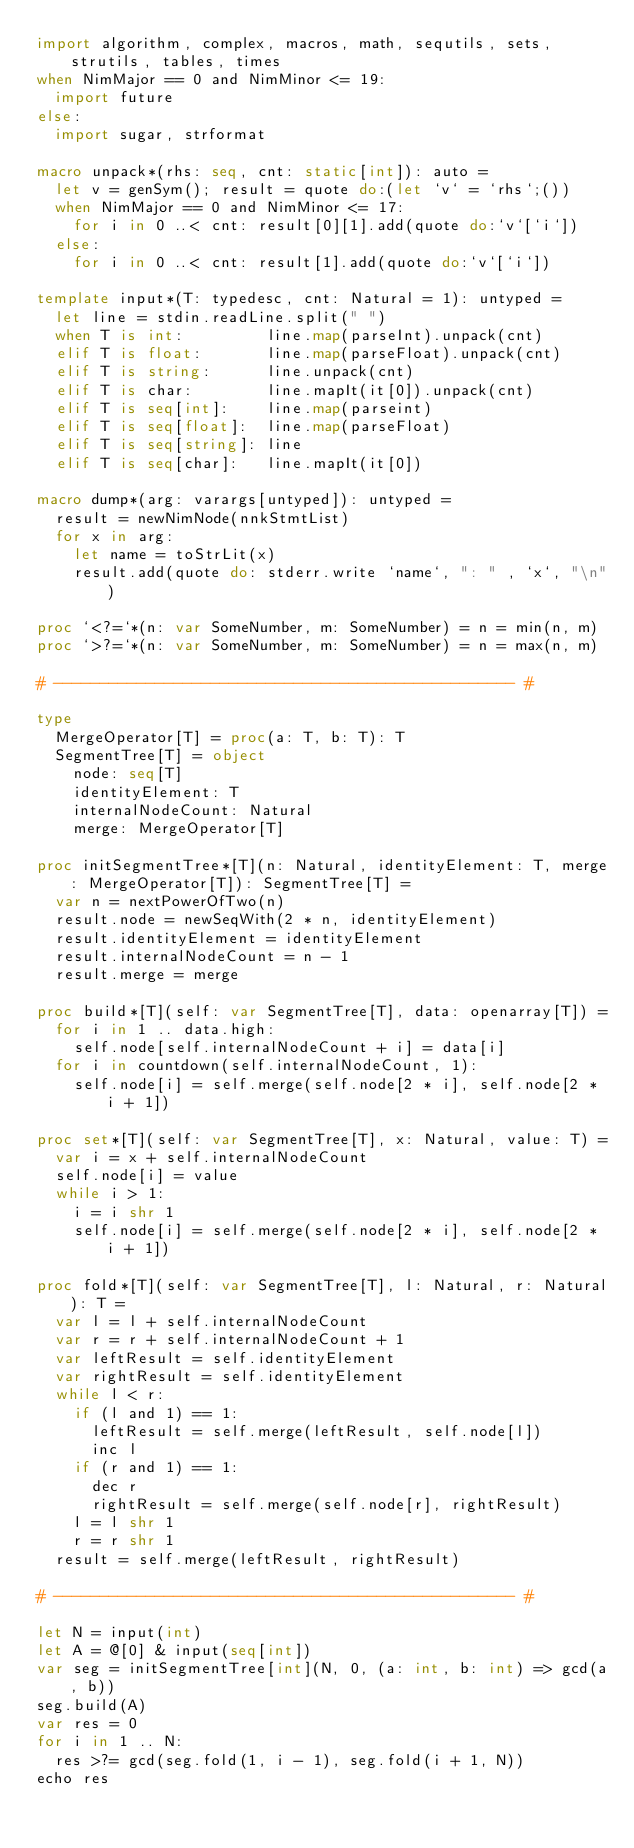Convert code to text. <code><loc_0><loc_0><loc_500><loc_500><_Nim_>import algorithm, complex, macros, math, sequtils, sets, strutils, tables, times
when NimMajor == 0 and NimMinor <= 19:
  import future
else:
  import sugar, strformat

macro unpack*(rhs: seq, cnt: static[int]): auto =
  let v = genSym(); result = quote do:(let `v` = `rhs`;())
  when NimMajor == 0 and NimMinor <= 17:
    for i in 0 ..< cnt: result[0][1].add(quote do:`v`[`i`])
  else:
    for i in 0 ..< cnt: result[1].add(quote do:`v`[`i`])

template input*(T: typedesc, cnt: Natural = 1): untyped =
  let line = stdin.readLine.split(" ")
  when T is int:         line.map(parseInt).unpack(cnt)
  elif T is float:       line.map(parseFloat).unpack(cnt)
  elif T is string:      line.unpack(cnt)
  elif T is char:        line.mapIt(it[0]).unpack(cnt)
  elif T is seq[int]:    line.map(parseint)
  elif T is seq[float]:  line.map(parseFloat)
  elif T is seq[string]: line
  elif T is seq[char]:   line.mapIt(it[0])

macro dump*(arg: varargs[untyped]): untyped =
  result = newNimNode(nnkStmtList)
  for x in arg:
    let name = toStrLit(x)
    result.add(quote do: stderr.write `name`, ": " , `x`, "\n")

proc `<?=`*(n: var SomeNumber, m: SomeNumber) = n = min(n, m)
proc `>?=`*(n: var SomeNumber, m: SomeNumber) = n = max(n, m)

# -------------------------------------------------- #

type
  MergeOperator[T] = proc(a: T, b: T): T
  SegmentTree[T] = object
    node: seq[T]
    identityElement: T
    internalNodeCount: Natural
    merge: MergeOperator[T]
 
proc initSegmentTree*[T](n: Natural, identityElement: T, merge: MergeOperator[T]): SegmentTree[T] =
  var n = nextPowerOfTwo(n)
  result.node = newSeqWith(2 * n, identityElement)
  result.identityElement = identityElement
  result.internalNodeCount = n - 1
  result.merge = merge

proc build*[T](self: var SegmentTree[T], data: openarray[T]) =
  for i in 1 .. data.high:
    self.node[self.internalNodeCount + i] = data[i]
  for i in countdown(self.internalNodeCount, 1):
    self.node[i] = self.merge(self.node[2 * i], self.node[2 * i + 1])

proc set*[T](self: var SegmentTree[T], x: Natural, value: T) =
  var i = x + self.internalNodeCount
  self.node[i] = value
  while i > 1:
    i = i shr 1
    self.node[i] = self.merge(self.node[2 * i], self.node[2 * i + 1])

proc fold*[T](self: var SegmentTree[T], l: Natural, r: Natural): T =
  var l = l + self.internalNodeCount
  var r = r + self.internalNodeCount + 1
  var leftResult = self.identityElement
  var rightResult = self.identityElement
  while l < r:
    if (l and 1) == 1:
      leftResult = self.merge(leftResult, self.node[l])
      inc l
    if (r and 1) == 1:
      dec r
      rightResult = self.merge(self.node[r], rightResult)
    l = l shr 1
    r = r shr 1
  result = self.merge(leftResult, rightResult)

# -------------------------------------------------- #

let N = input(int)
let A = @[0] & input(seq[int])
var seg = initSegmentTree[int](N, 0, (a: int, b: int) => gcd(a, b))
seg.build(A)
var res = 0
for i in 1 .. N:
  res >?= gcd(seg.fold(1, i - 1), seg.fold(i + 1, N))
echo res</code> 